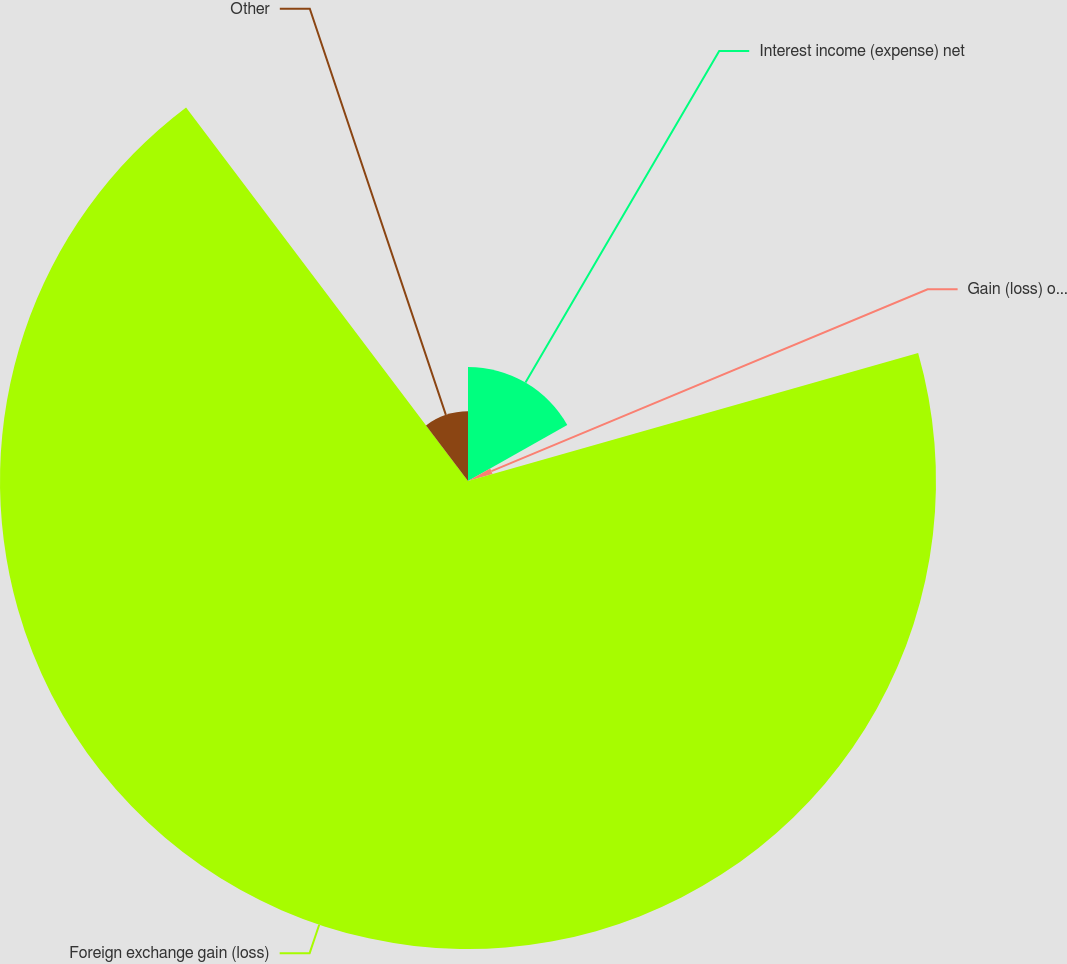Convert chart to OTSL. <chart><loc_0><loc_0><loc_500><loc_500><pie_chart><fcel>Interest income (expense) net<fcel>Gain (loss) on sale and<fcel>Foreign exchange gain (loss)<fcel>Other<nl><fcel>16.83%<fcel>3.76%<fcel>69.12%<fcel>10.29%<nl></chart> 